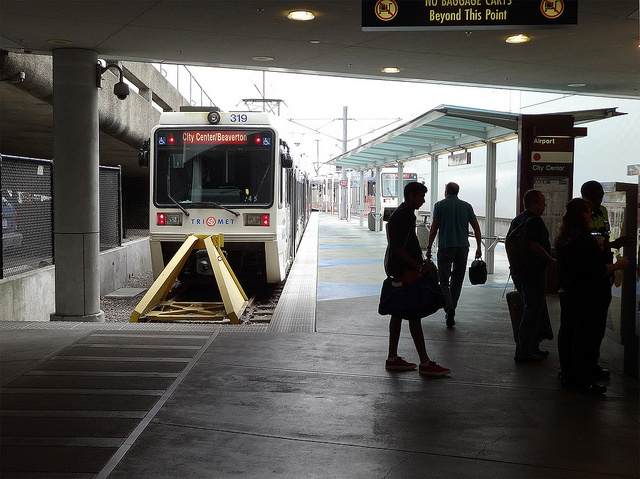Describe the objects in this image and their specific colors. I can see train in black, white, darkgray, and gray tones, people in black and gray tones, people in black and gray tones, people in black, gray, darkgray, and lightgray tones, and people in black, gray, darkgray, and lightgray tones in this image. 